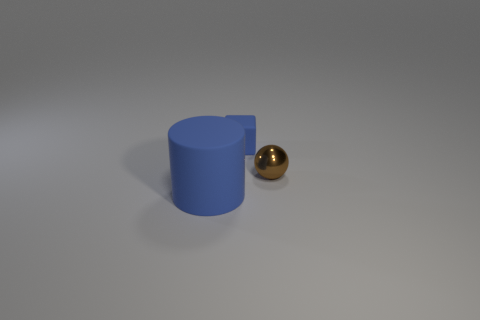Add 2 tiny brown metal spheres. How many objects exist? 5 Subtract 1 cubes. How many cubes are left? 0 Subtract all blue matte objects. Subtract all small cyan balls. How many objects are left? 1 Add 2 big blue rubber cylinders. How many big blue rubber cylinders are left? 3 Add 2 small cubes. How many small cubes exist? 3 Subtract 0 cyan balls. How many objects are left? 3 Subtract all gray cylinders. Subtract all purple balls. How many cylinders are left? 1 